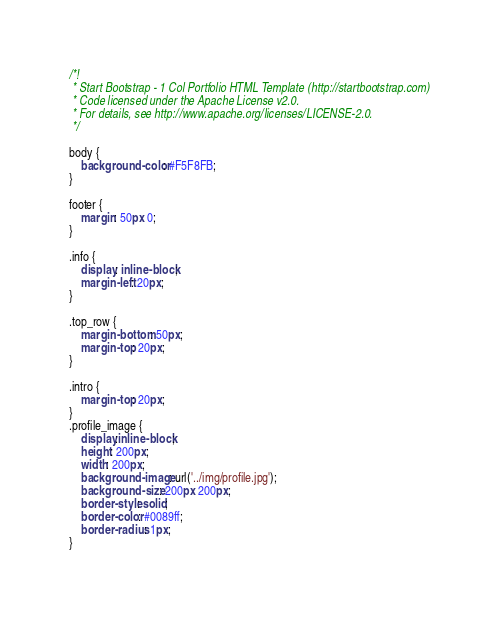Convert code to text. <code><loc_0><loc_0><loc_500><loc_500><_CSS_>/*!
 * Start Bootstrap - 1 Col Portfolio HTML Template (http://startbootstrap.com)
 * Code licensed under the Apache License v2.0.
 * For details, see http://www.apache.org/licenses/LICENSE-2.0.
 */

body {
    background-color: #F5F8FB;
}

footer {
    margin: 50px 0;
}

.info {
    display: inline-block;
    margin-left: 20px;
}

.top_row {
    margin-bottom: 50px;
    margin-top: 20px;
}

.intro {
    margin-top: 20px;
}
.profile_image {
    display:inline-block;
    height: 200px;
    width: 200px;
    background-image: url('../img/profile.jpg');
    background-size: 200px 200px;
    border-style: solid;
    border-color: #0089ff;
    border-radius: 1px;
}
</code> 